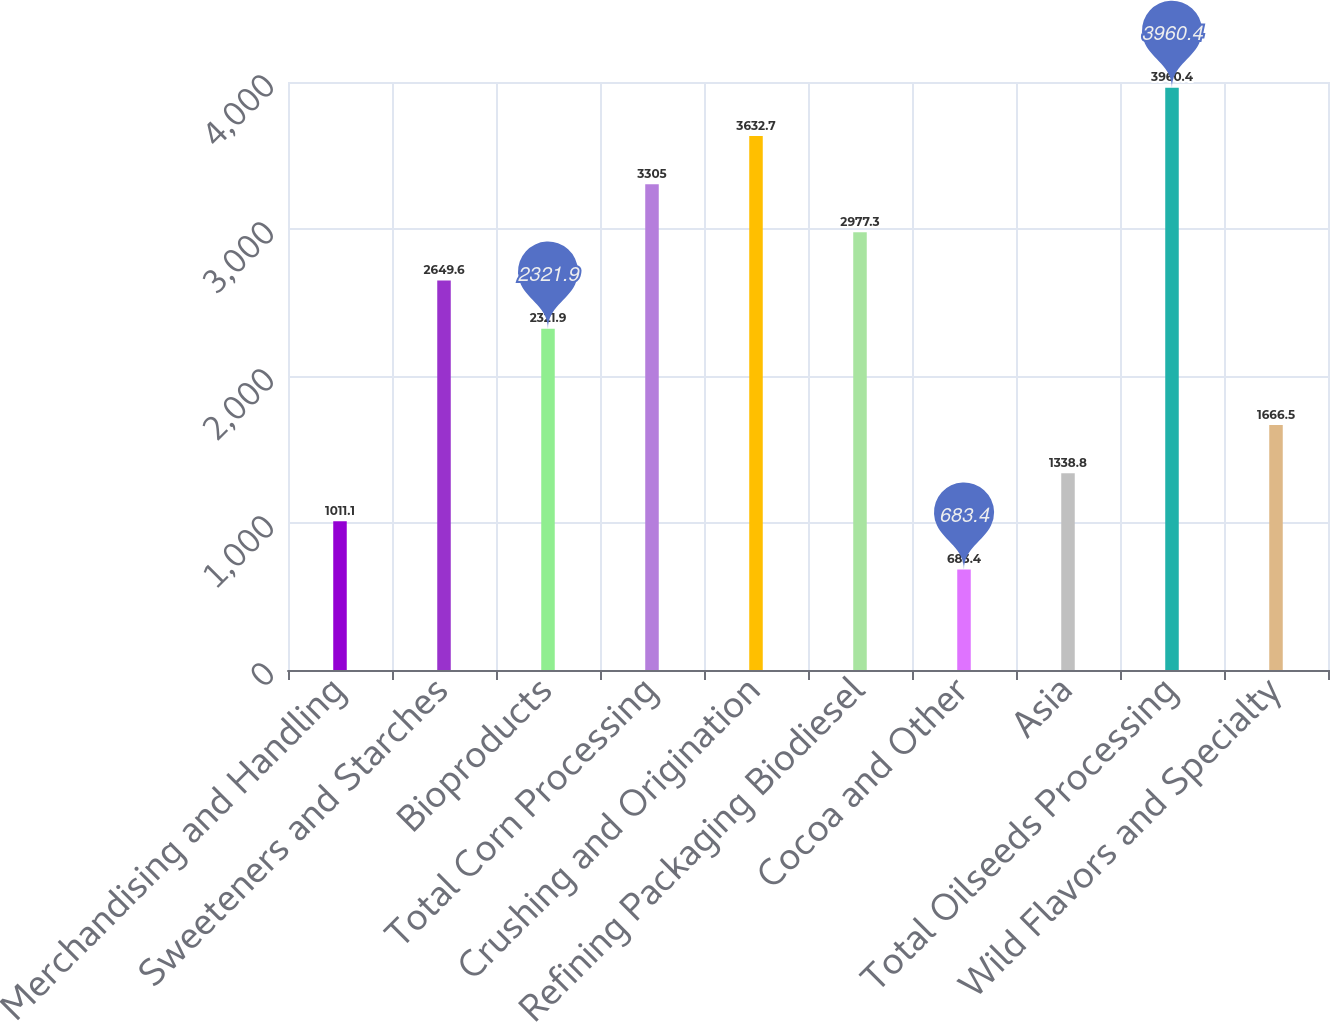<chart> <loc_0><loc_0><loc_500><loc_500><bar_chart><fcel>Merchandising and Handling<fcel>Sweeteners and Starches<fcel>Bioproducts<fcel>Total Corn Processing<fcel>Crushing and Origination<fcel>Refining Packaging Biodiesel<fcel>Cocoa and Other<fcel>Asia<fcel>Total Oilseeds Processing<fcel>Wild Flavors and Specialty<nl><fcel>1011.1<fcel>2649.6<fcel>2321.9<fcel>3305<fcel>3632.7<fcel>2977.3<fcel>683.4<fcel>1338.8<fcel>3960.4<fcel>1666.5<nl></chart> 